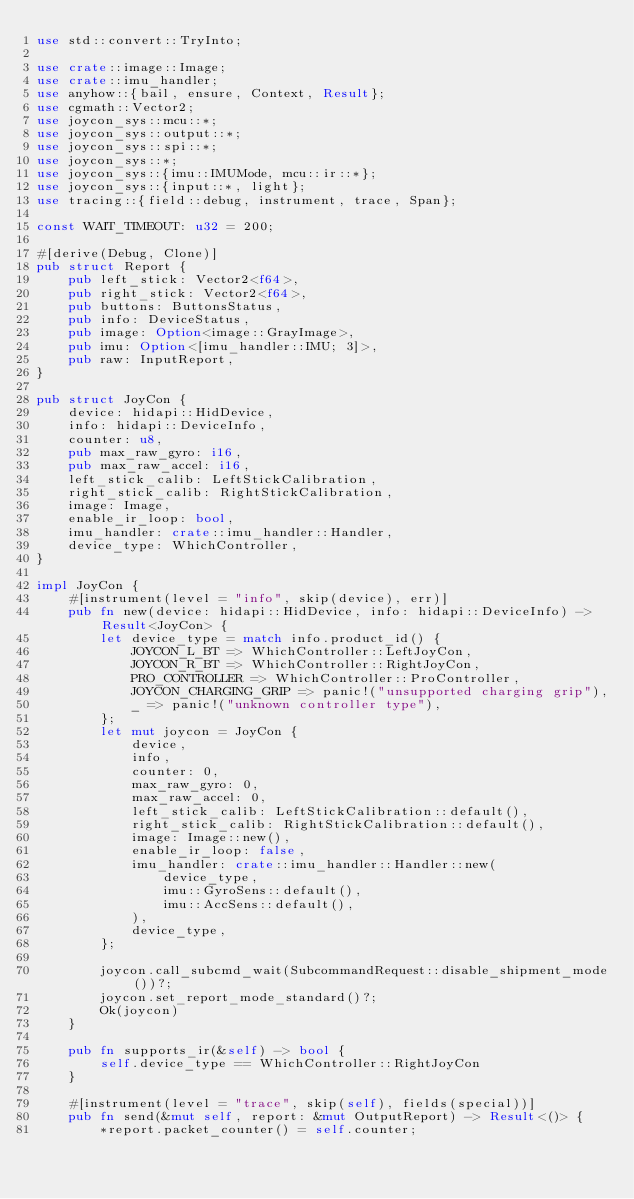<code> <loc_0><loc_0><loc_500><loc_500><_Rust_>use std::convert::TryInto;

use crate::image::Image;
use crate::imu_handler;
use anyhow::{bail, ensure, Context, Result};
use cgmath::Vector2;
use joycon_sys::mcu::*;
use joycon_sys::output::*;
use joycon_sys::spi::*;
use joycon_sys::*;
use joycon_sys::{imu::IMUMode, mcu::ir::*};
use joycon_sys::{input::*, light};
use tracing::{field::debug, instrument, trace, Span};

const WAIT_TIMEOUT: u32 = 200;

#[derive(Debug, Clone)]
pub struct Report {
    pub left_stick: Vector2<f64>,
    pub right_stick: Vector2<f64>,
    pub buttons: ButtonsStatus,
    pub info: DeviceStatus,
    pub image: Option<image::GrayImage>,
    pub imu: Option<[imu_handler::IMU; 3]>,
    pub raw: InputReport,
}

pub struct JoyCon {
    device: hidapi::HidDevice,
    info: hidapi::DeviceInfo,
    counter: u8,
    pub max_raw_gyro: i16,
    pub max_raw_accel: i16,
    left_stick_calib: LeftStickCalibration,
    right_stick_calib: RightStickCalibration,
    image: Image,
    enable_ir_loop: bool,
    imu_handler: crate::imu_handler::Handler,
    device_type: WhichController,
}

impl JoyCon {
    #[instrument(level = "info", skip(device), err)]
    pub fn new(device: hidapi::HidDevice, info: hidapi::DeviceInfo) -> Result<JoyCon> {
        let device_type = match info.product_id() {
            JOYCON_L_BT => WhichController::LeftJoyCon,
            JOYCON_R_BT => WhichController::RightJoyCon,
            PRO_CONTROLLER => WhichController::ProController,
            JOYCON_CHARGING_GRIP => panic!("unsupported charging grip"),
            _ => panic!("unknown controller type"),
        };
        let mut joycon = JoyCon {
            device,
            info,
            counter: 0,
            max_raw_gyro: 0,
            max_raw_accel: 0,
            left_stick_calib: LeftStickCalibration::default(),
            right_stick_calib: RightStickCalibration::default(),
            image: Image::new(),
            enable_ir_loop: false,
            imu_handler: crate::imu_handler::Handler::new(
                device_type,
                imu::GyroSens::default(),
                imu::AccSens::default(),
            ),
            device_type,
        };

        joycon.call_subcmd_wait(SubcommandRequest::disable_shipment_mode())?;
        joycon.set_report_mode_standard()?;
        Ok(joycon)
    }

    pub fn supports_ir(&self) -> bool {
        self.device_type == WhichController::RightJoyCon
    }

    #[instrument(level = "trace", skip(self), fields(special))]
    pub fn send(&mut self, report: &mut OutputReport) -> Result<()> {
        *report.packet_counter() = self.counter;</code> 